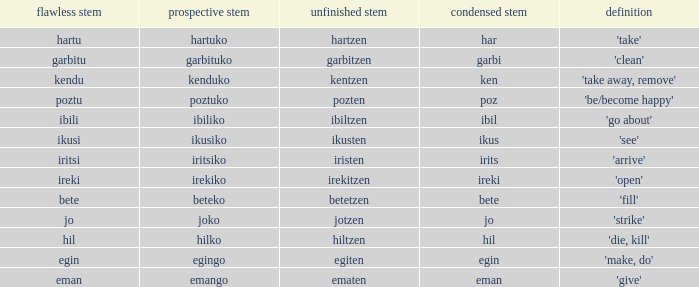Name the perfect stem for jo 1.0. 